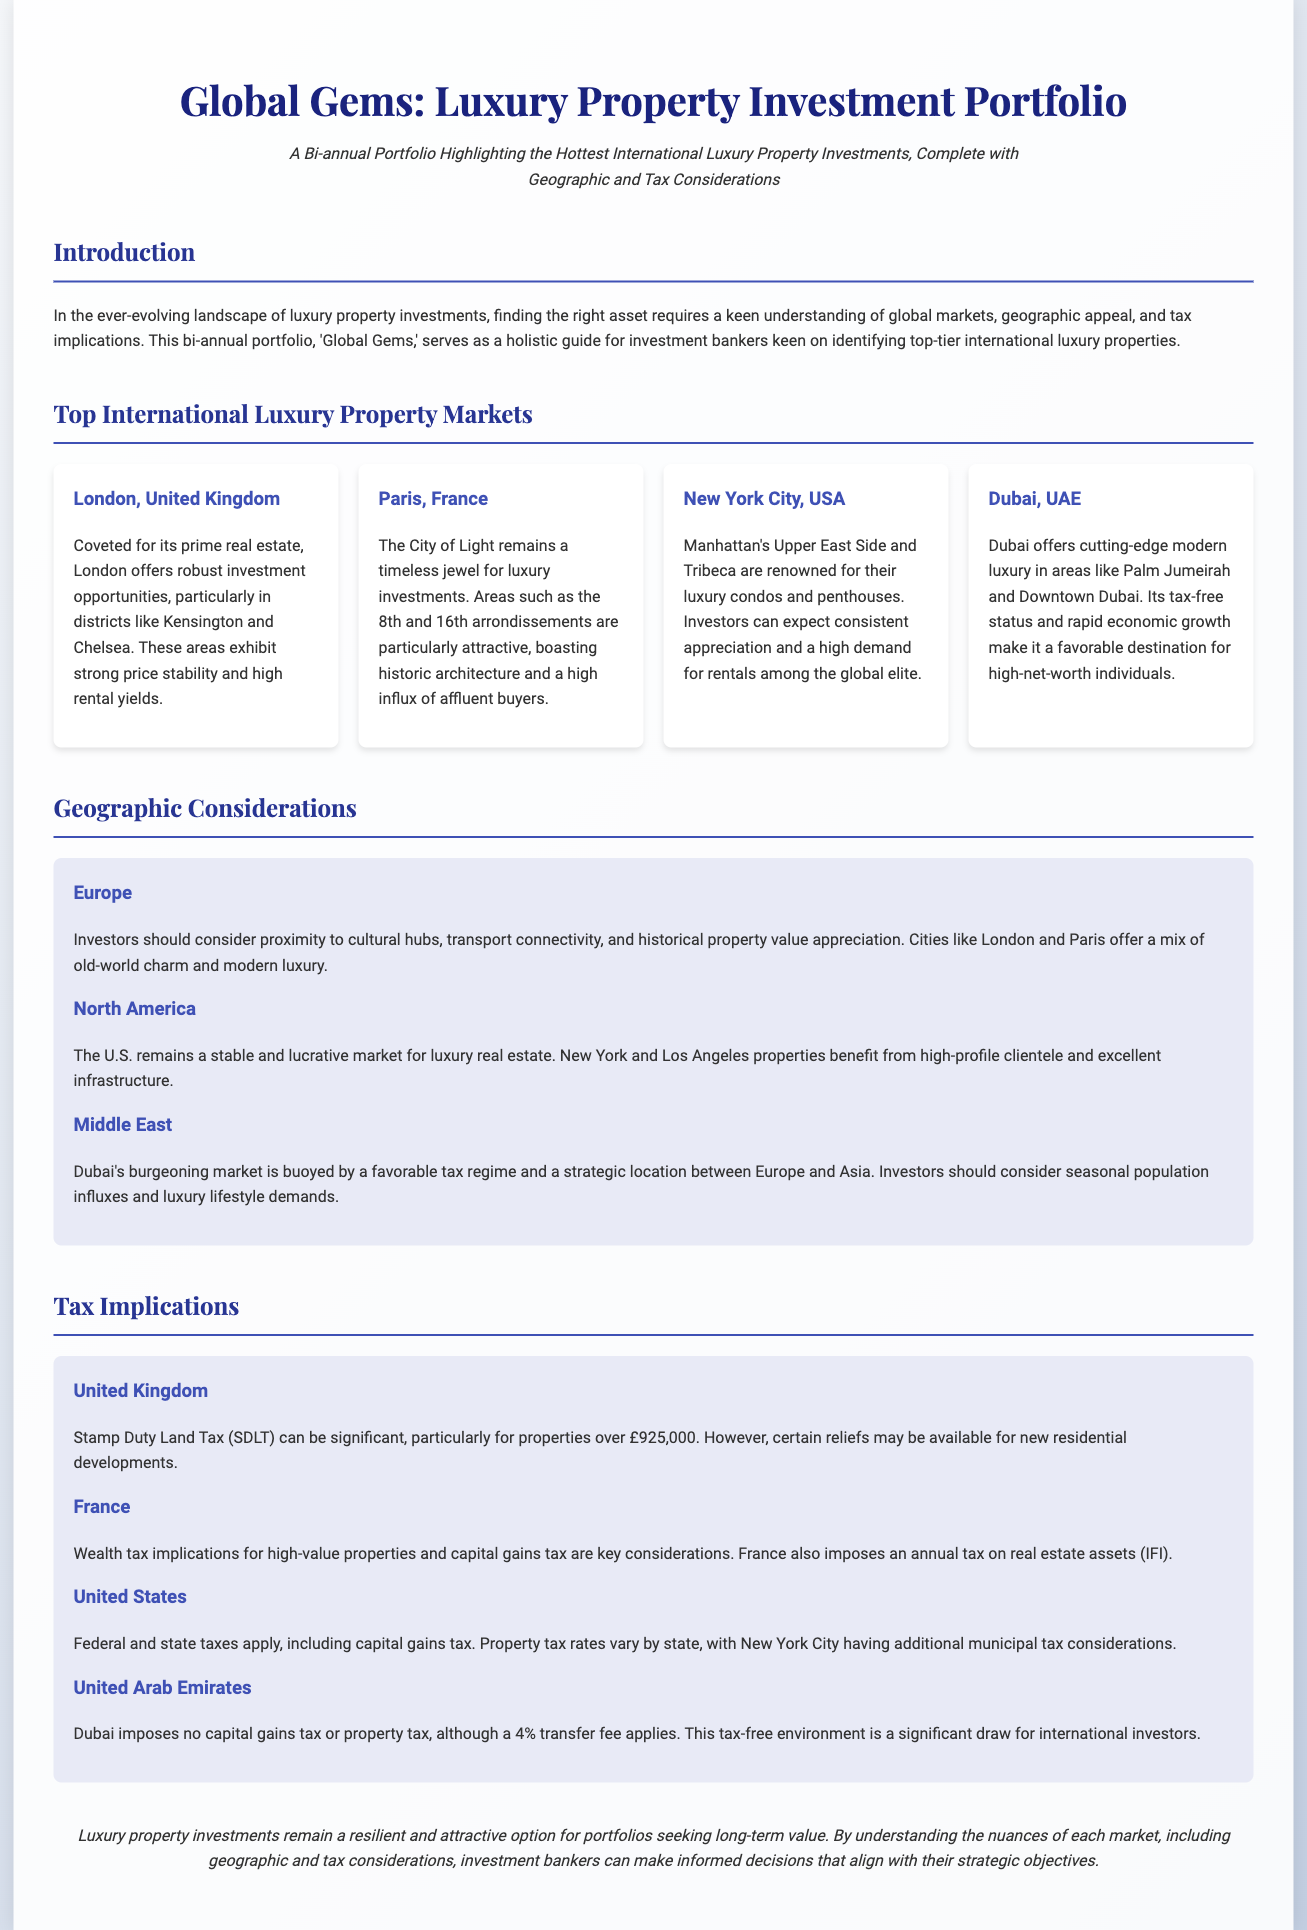What is the title of the document? The title of the document is prominently displayed in the header as "Global Gems: Luxury Property Investment Portfolio."
Answer: Global Gems: Luxury Property Investment Portfolio How often is the portfolio published? The document specifies that this is a bi-annual portfolio, indicating it is published twice a year.
Answer: Bi-annual Which city in the UK is highlighted for luxury investments? The document mentions London, specifically noting areas like Kensington and Chelsea for luxury investments.
Answer: London What tax does the UAE impose on property? The document states that Dubai imposes a 4% transfer fee but no capital gains tax or property tax.
Answer: 4% transfer fee Which U.S. city is mentioned for luxury condos? The document highlights New York City, specifically the Upper East Side and Tribeca for its luxury condos and penthouses.
Answer: New York City What is a key consideration for investors in the Middle East? Investors should consider seasonal population influxes and luxury lifestyle demands in Dubai’s burgeoning market.
Answer: Seasonal population influxes What is the annual tax on real estate assets in France? The document states that France imposes an annual tax on real estate assets called "IFI."
Answer: IFI What should investors look for in European markets? The document suggests that investors should consider proximity to cultural hubs and transport connectivity in European markets.
Answer: Cultural hubs and transport connectivity What is a tax implication for high-value properties in France? The document mentions that wealth tax implications and capital gains tax are key considerations for high-value properties in France.
Answer: Wealth tax implications Which luxury property area in Dubai is mentioned? The document specifies Palm Jumeirah as one of the luxury property areas in Dubai.
Answer: Palm Jumeirah 